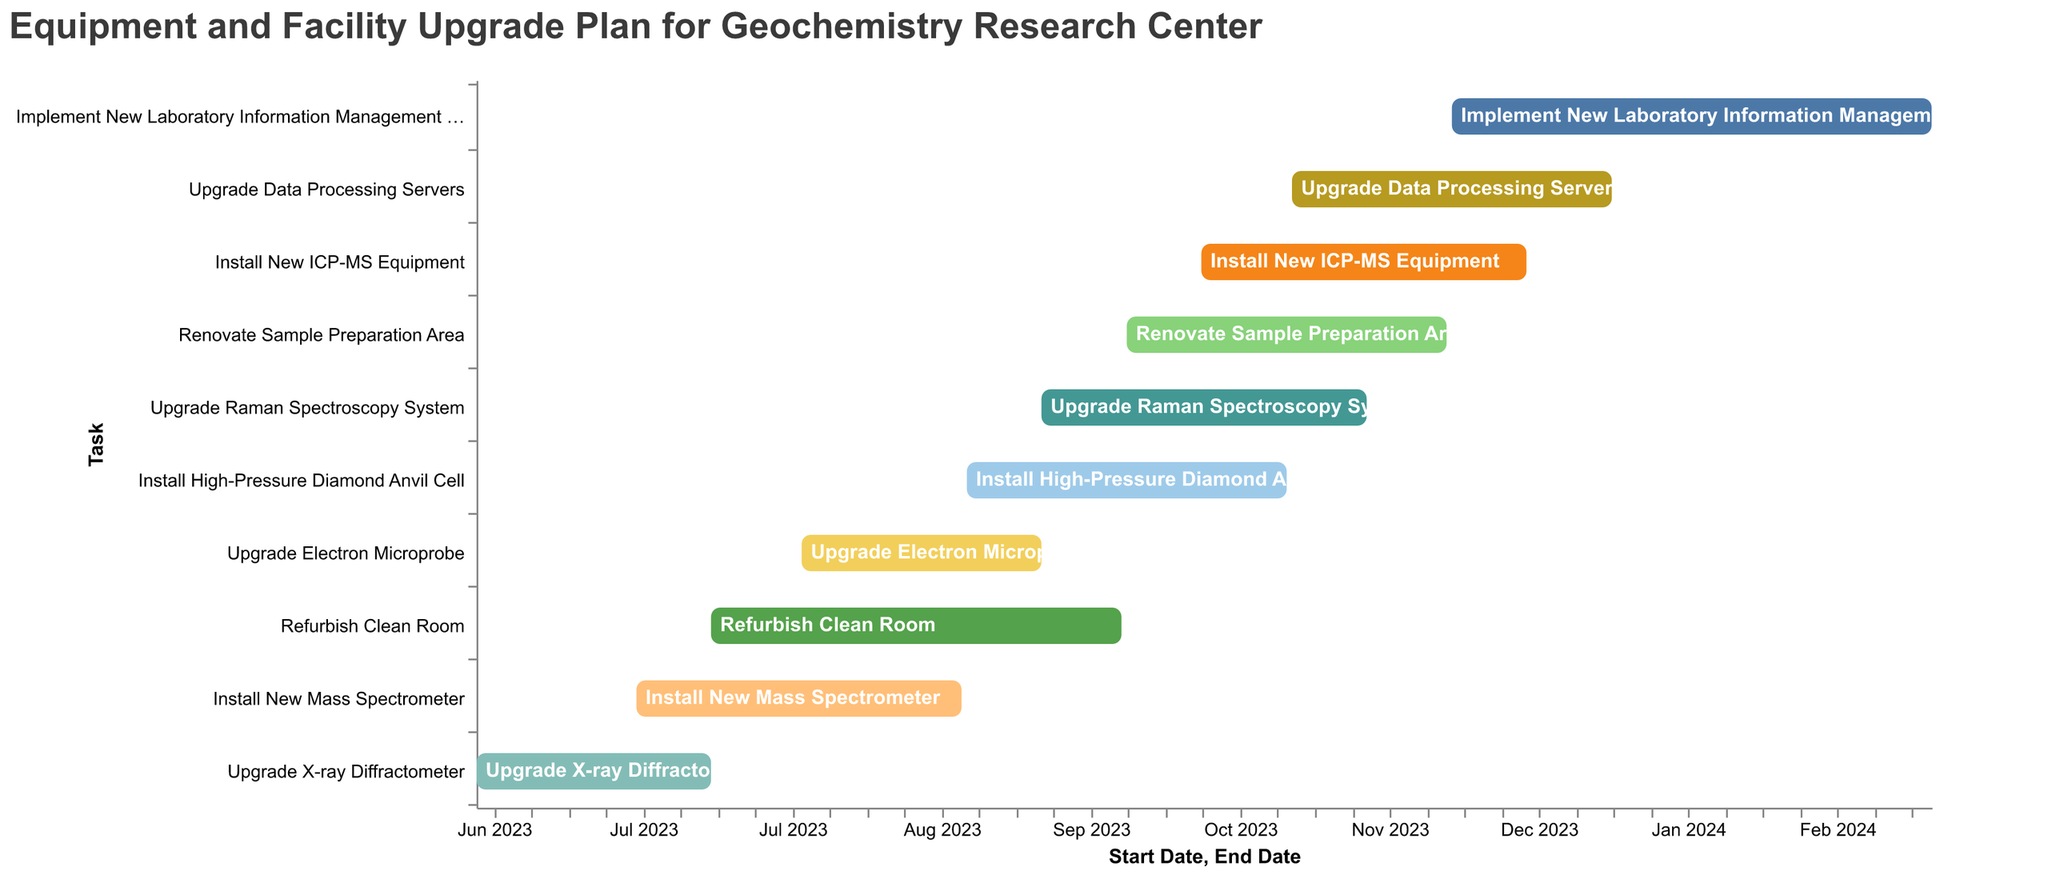What is the title of the chart? The title is usually found at the top of the chart and provides a description of what the chart represents. In this case, the title is "Equipment and Facility Upgrade Plan for Geochemistry Research Center".
Answer: Equipment and Facility Upgrade Plan for Geochemistry Research Center How many tasks are displayed in the Gantt Chart? By counting the bars representing each task on the Gantt Chart, we can determine the total number of tasks. There are 10 tasks listed.
Answer: 10 Which task has the longest duration? The duration of each task is represented by the length of its corresponding bar. The task "Implement New Laboratory Information Management System" has a duration of 91 days, which is the longest.
Answer: Implement New Laboratory Information Management System What is the start date for refurbishing the clean room? Each bar in the Gantt Chart starts at a specific point on the x-axis, representing the start date. The task "Refurbish Clean Room" starts on 2023-07-15.
Answer: 2023-07-15 Which tasks are scheduled to start in October 2023? By examining the bars that align with October 2023 on the x-axis, we can identify the tasks that start in that month. "Renovate Sample Preparation Area" starts on 2023-10-01, and "Install New ICP-MS Equipment" starts on 2023-10-15.
Answer: Renovate Sample Preparation Area, Install New ICP-MS Equipment If "Upgrade X-ray Diffractometer" finishes on 2023-07-15, when is the next task starting? By finding the end date of "Upgrade X-ray Diffractometer" and checking the start dates of subsequent tasks, we see that the next task, "Install New Mass Spectrometer", starts on 2023-07-01.
Answer: 2023-07-01 Do any tasks overlap with "Upgrade Data Processing Servers"? We can determine overlap by checking if other tasks' time spans intersect with the period of "Upgrade Data Processing Servers" (2023-11-01 to 2023-12-31). Tasks that overlap include "Install New ICP-MS Equipment" and "Implement New Laboratory Information Management System".
Answer: Yes Which tasks are scheduled to be completed by the end of September 2023? By checking the end dates on the x-axis, we find tasks ending on or before 2023-09-30. These tasks include "Upgrade X-ray Diffractometer", "Install New Mass Spectrometer", "Refurbish Clean Room", and "Upgrade Electron Microprobe".
Answer: Upgrade X-ray Diffractometer, Install New Mass Spectrometer, Refurbish Clean Room, Upgrade Electron Microprobe What tasks are ongoing in November 2023? By identifying tasks that span across November 2023 on the Gantt Chart, we see that the tasks ongoing are "Install High-Pressure Diamond Anvil Cell", "Upgrade Raman Spectroscopy System", "Renovate Sample Preparation Area", "Install New ICP-MS Equipment", and "Upgrade Data Processing Servers".
Answer: Install High-Pressure Diamond Anvil Cell, Upgrade Raman Spectroscopy System, Renovate Sample Preparation Area, Install New ICP-MS Equipment, Upgrade Data Processing Servers 